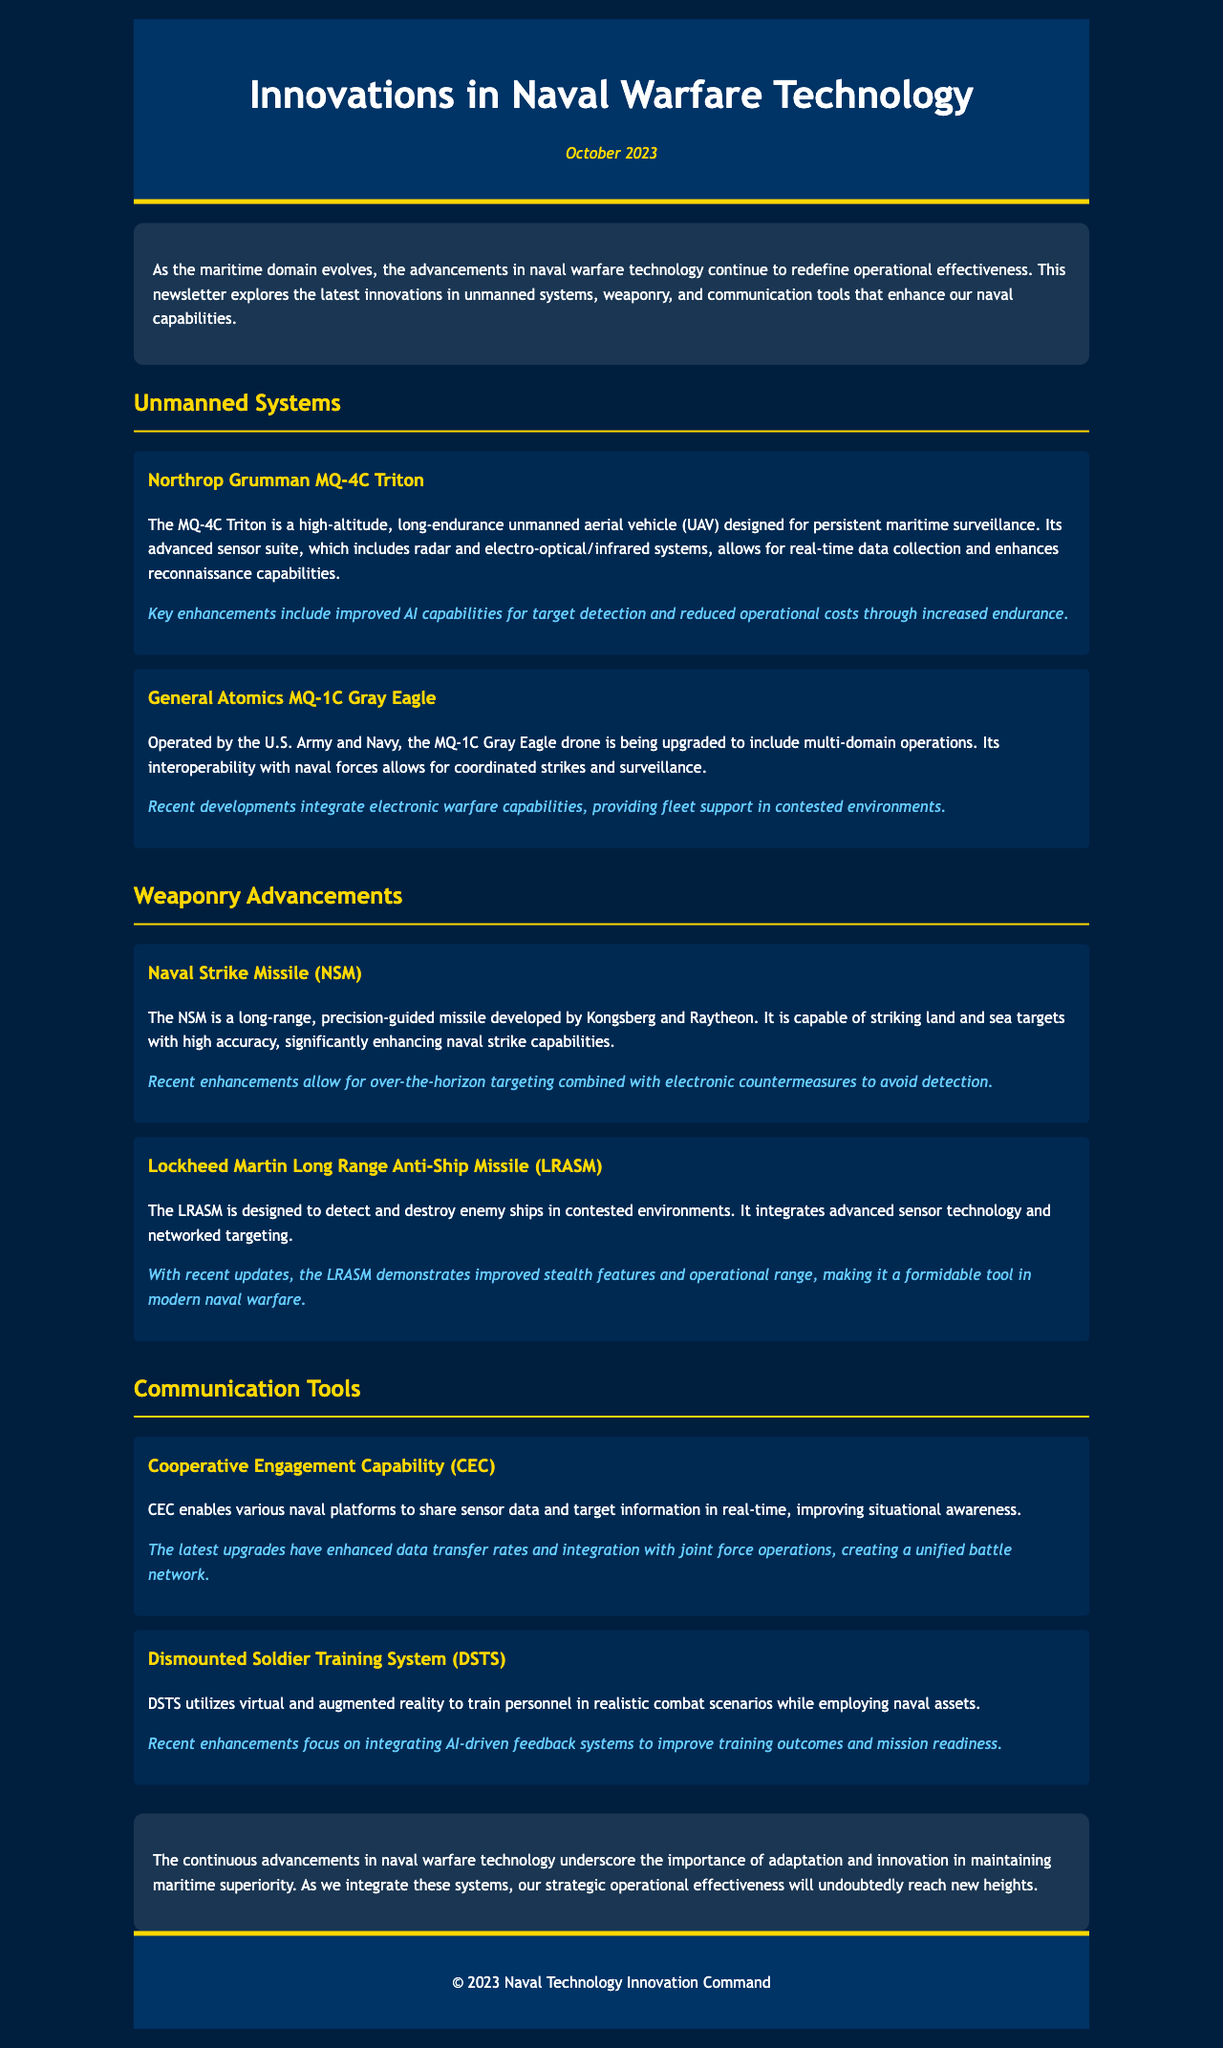What is the date of the newsletter? The date is mentioned at the top of the document under the header section.
Answer: October 2023 What unmanned aerial vehicle is designed for persistent maritime surveillance? This information is specifically given in the section about unmanned systems, describing the MQ-4C Triton.
Answer: MQ-4C Triton Which company developed the Naval Strike Missile? The document mentions the developers of NSM within the weaponry advancements section.
Answer: Kongsberg and Raytheon What capability does the Cooperative Engagement Capability (CEC) enhance? The document states that CEC improves a specific operational feature for naval platforms.
Answer: Situational awareness What recent advancement was noted for the LRASM? This relates to improvements in stealth and operational range as indicated in the text about weaponry advancements.
Answer: Improved stealth features and operational range What system utilizes virtual and augmented reality for training? The document describes this specific system within the communication tools section.
Answer: Dismounted Soldier Training System (DSTS) What is highlighted as a key advantage of the MQ-1C Gray Eagle? The advancements section mentions the specific operational benefit related to electronic warfare capabilities.
Answer: Electronic warfare capabilities What overall theme does the conclusion emphasize regarding naval warfare technology? The conclusion reflects an overarching message about the necessity of adaptation and innovation in naval technology.
Answer: Maritime superiority 